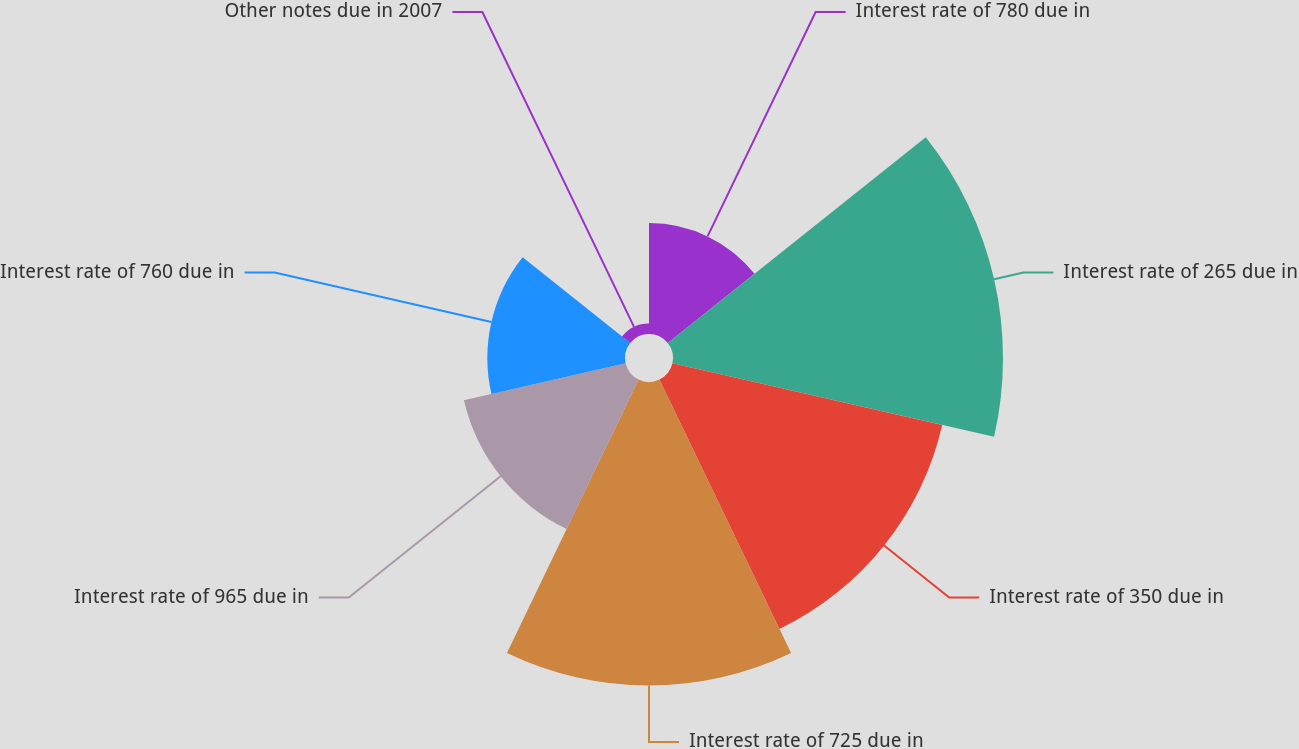Convert chart. <chart><loc_0><loc_0><loc_500><loc_500><pie_chart><fcel>Interest rate of 780 due in<fcel>Interest rate of 265 due in<fcel>Interest rate of 350 due in<fcel>Interest rate of 725 due in<fcel>Interest rate of 965 due in<fcel>Interest rate of 760 due in<fcel>Other notes due in 2007<nl><fcel>8.31%<fcel>24.72%<fcel>20.73%<fcel>22.73%<fcel>12.42%<fcel>10.31%<fcel>0.79%<nl></chart> 